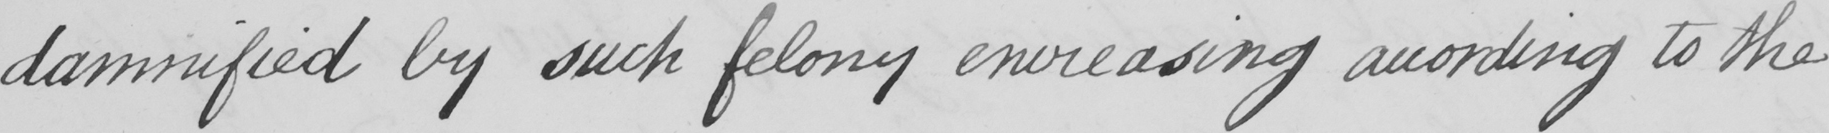Please transcribe the handwritten text in this image. damnified by such felony encreasing according to the 